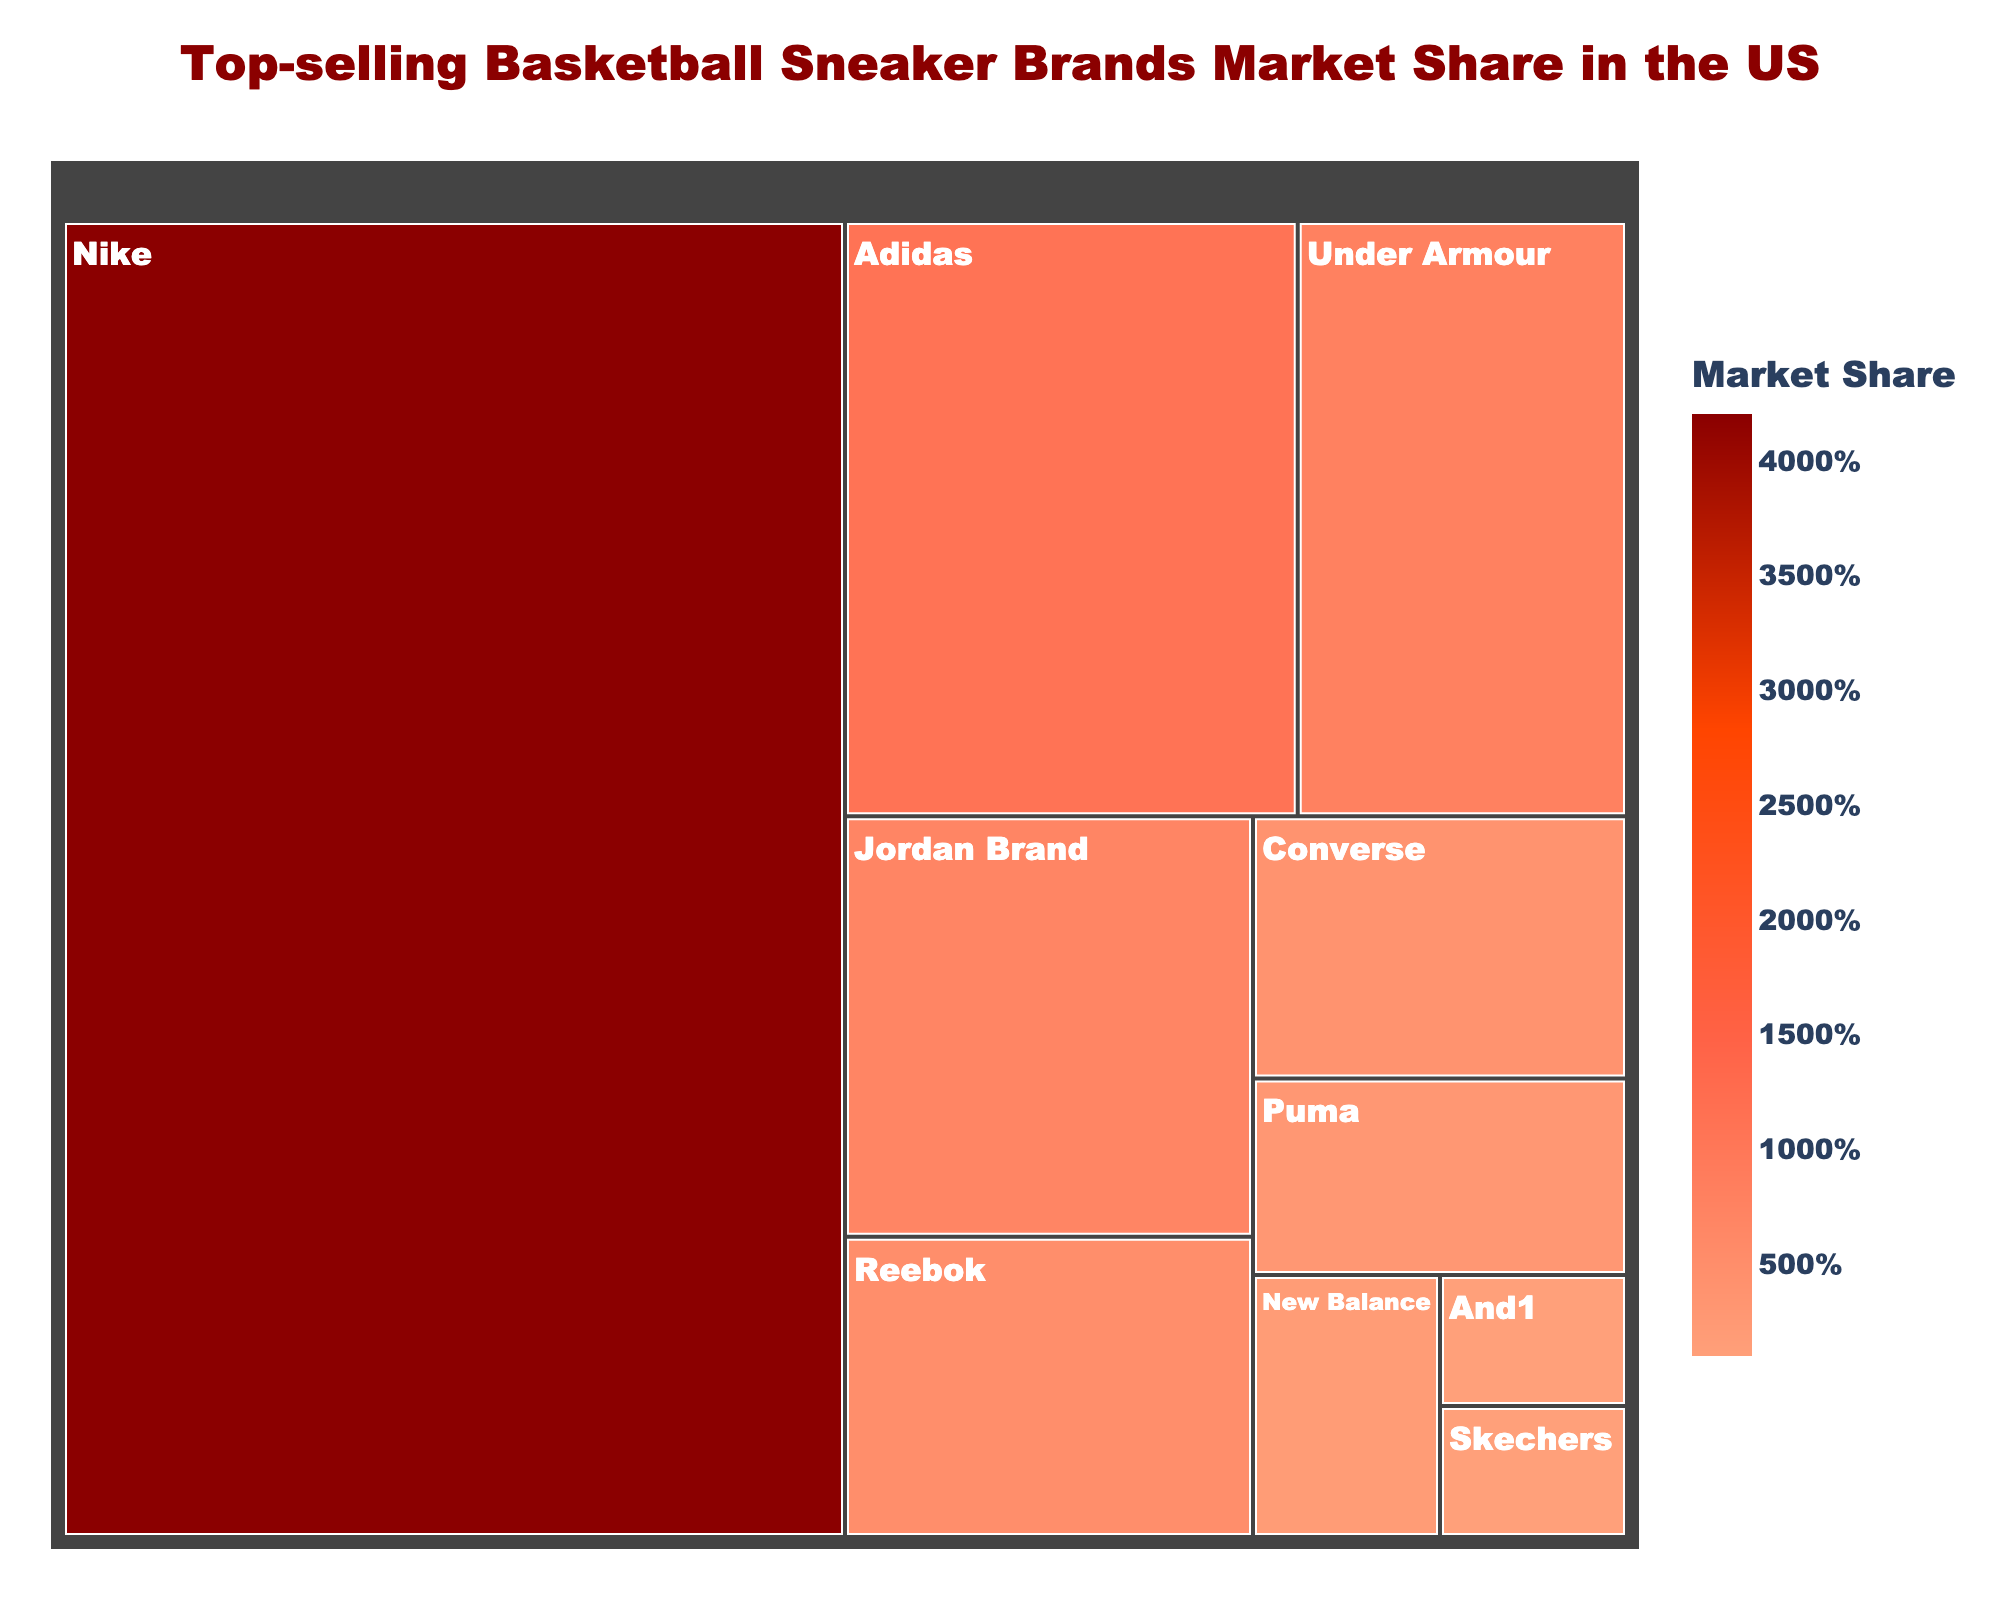What's the title of the treemap? The title is displayed in a larger and different colored font at the top of the treemap. It reads "Top-selling Basketball Sneaker Brands Market Share in the US".
Answer: Top-selling Basketball Sneaker Brands Market Share in the US Which brand has the largest market share? The largest section in the treemap is the one with the highest percentage value and is colored more prominently. Nike's section is the largest with 42%.
Answer: Nike How many brands have a market share of less than 5%? Identify all the sections with percentages below 5% by examining the treemap. Reebok, Converse, Puma, New Balance, Skechers, and And1 each have less than 5% market share. There are 6 brands in total.
Answer: 6 What is the combined market share of Nike and Adidas? Locate the market share values of Nike and Adidas, which are 42% and 11% respectively. Adding both values gives 53%.
Answer: 53% Which brand has the smallest market share and what is it? The smallest section in the treemap corresponds to the smallest percentage value. And1's section is the smallest with a 1% market share.
Answer: And1, 1% How does Under Armour's market share compare to Jordan Brand's? Compare the sections labeled under Under Armour and Jordan Brand. Under Armour has an 8% market share while Jordan Brand has 7%. Under Armour's market share is higher than Jordan Brand's by 1%.
Answer: Under Armour's market share is higher by 1% What is the difference in market share between Puma and Reebok? Locate the market share values of Puma and Reebok, which are 3% and 5% respectively. Subtract the smaller value from the larger one: 5% - 3% = 2%.
Answer: 2% What's the average market share of Adidas, Under Armour, and Jordan Brand combined? Sum their market shares: Adidas (11%), Under Armour (8%), Jordan Brand (7%). The sum is 11% + 8% + 7% = 26%. Divide by the number of brands, 26% / 3 ≈ 8.67%.
Answer: 8.67% Which brand has a similar market share to New Balance? Observe the sections around New Balance's 2% market share. Skechers also has a 1% market share close to New Balance’s.
Answer: Skechers 